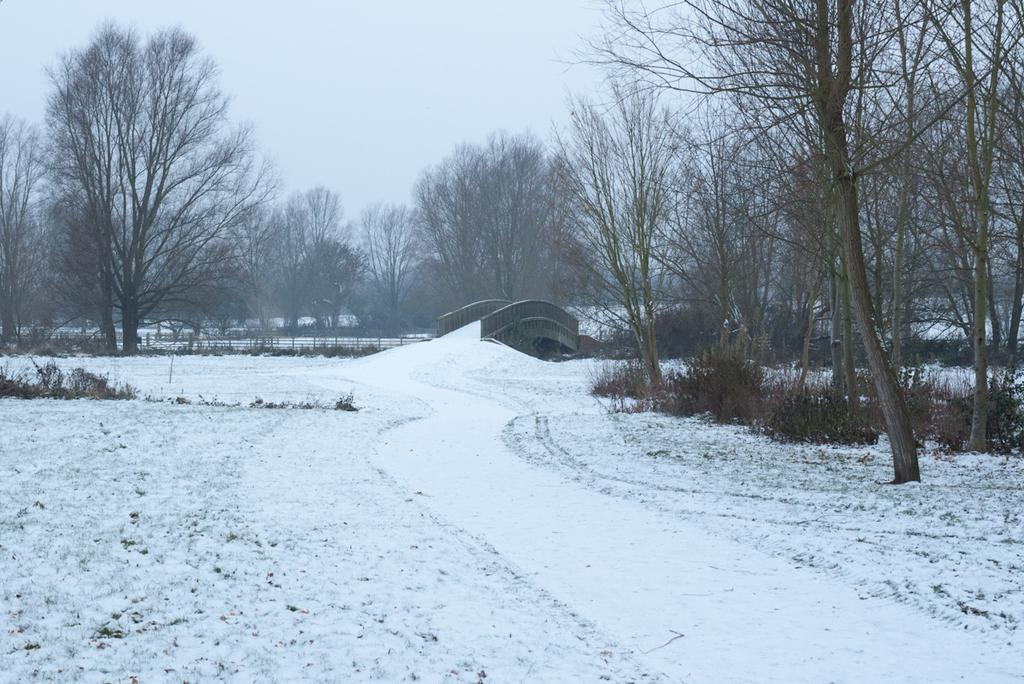What type of natural environment is depicted at the bottom of the image? There is snow at the bottom of the image. What structure can be seen in the middle of the image? There is a bridge in the middle of the image. What type of vegetation is present in the image? There are trees in the image. What is visible at the top of the image? The sky is visible at the top of the image. What type of record can be seen hanging from the trees in the image? There is no record present in the image; it features snow, a bridge, trees, and a sky. What is the pencil used for in the image? There is no pencil present in the image. 